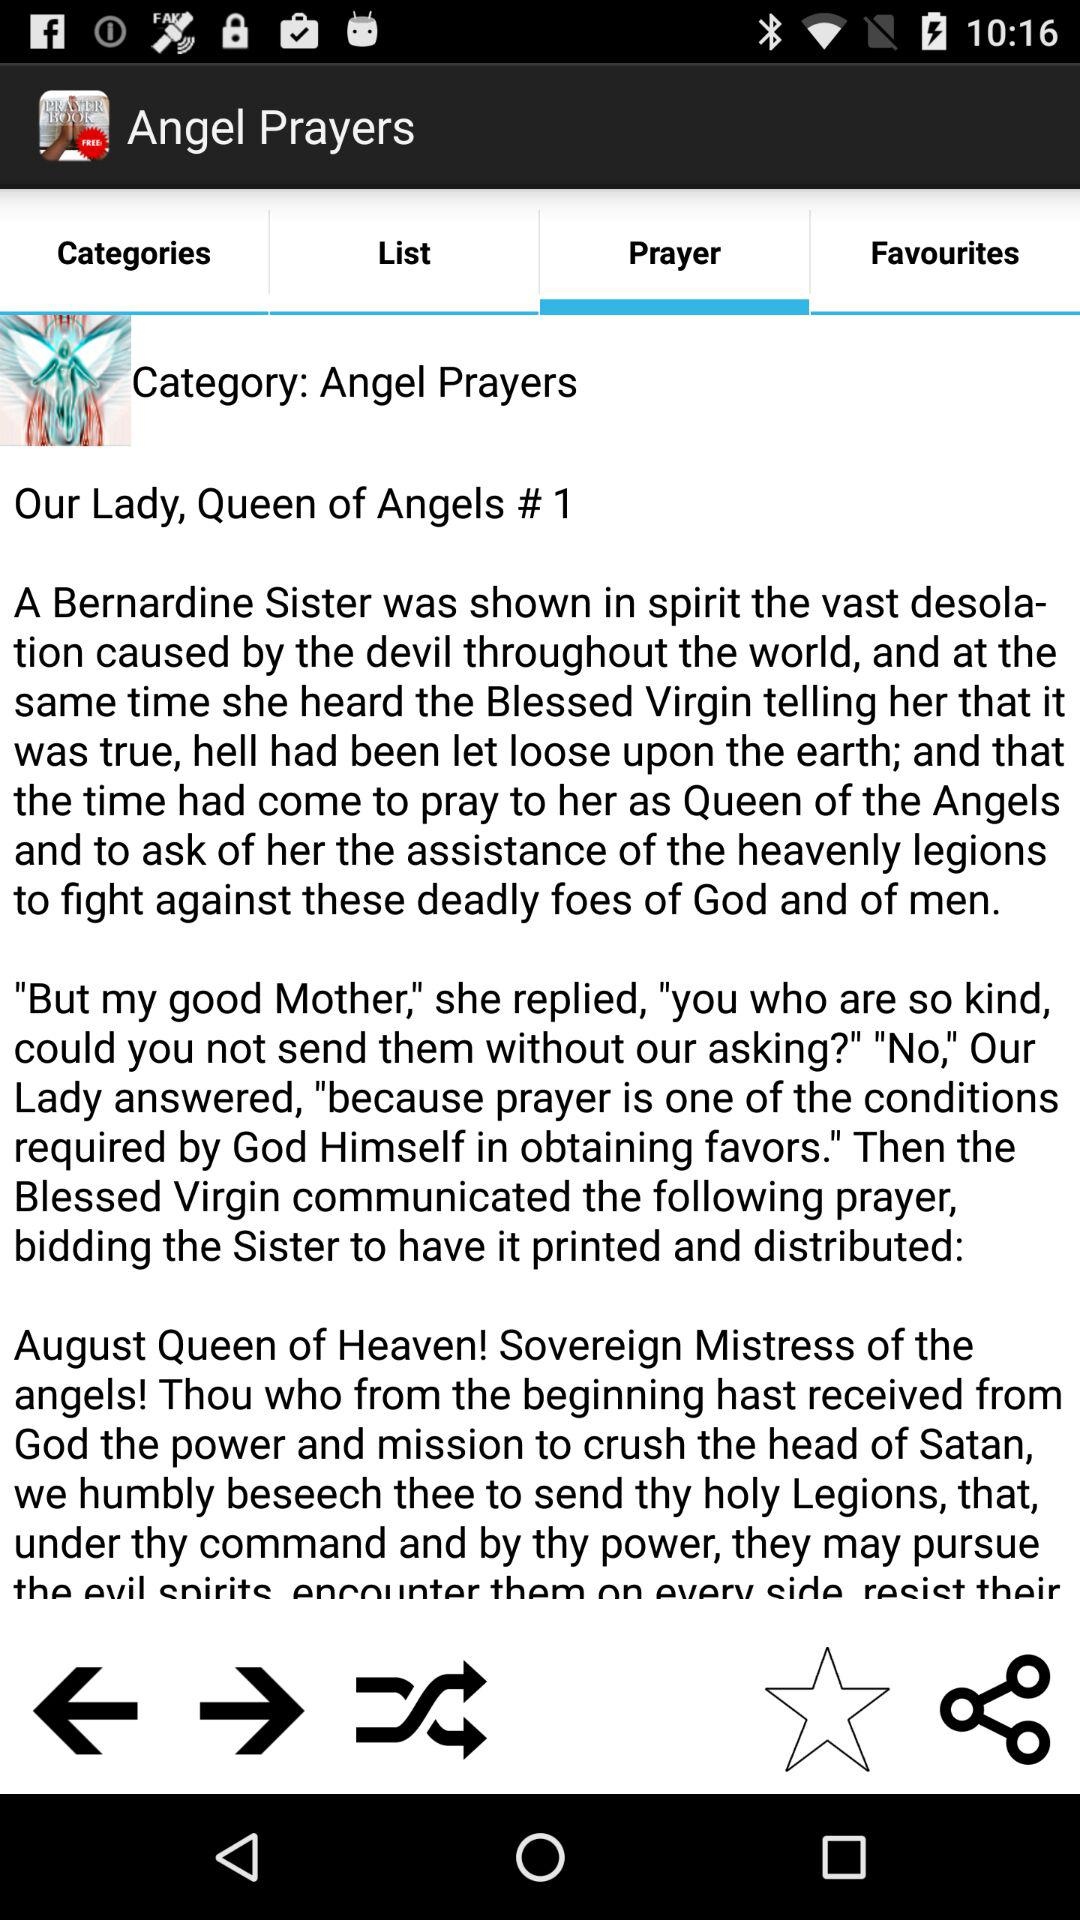How many notifications are there in "List"?
When the provided information is insufficient, respond with <no answer>. <no answer> 